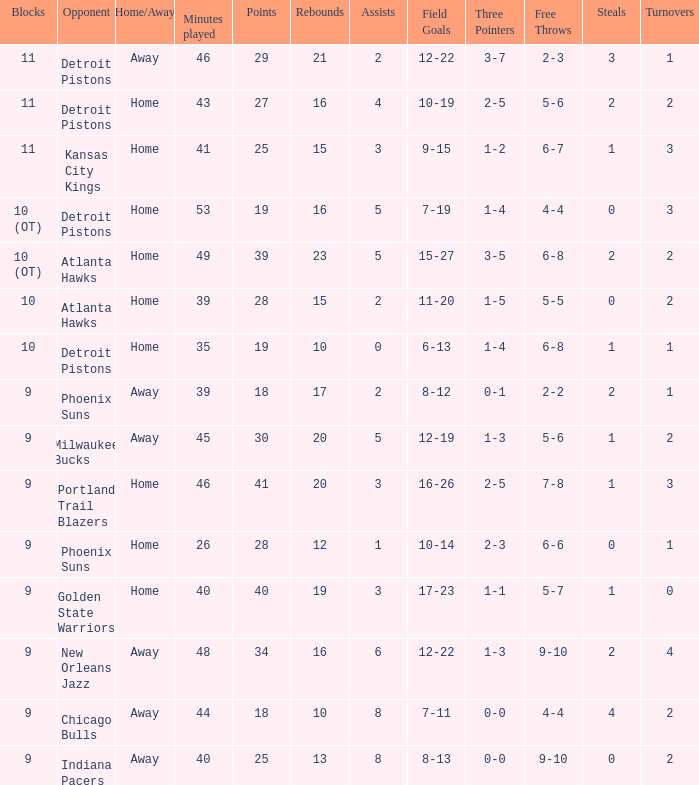How many points were there when there were less than 16 rebounds and 5 assists? 0.0. 